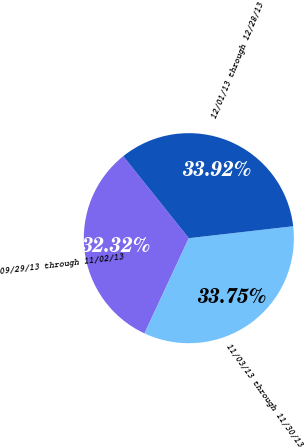Convert chart to OTSL. <chart><loc_0><loc_0><loc_500><loc_500><pie_chart><fcel>09/29/13 through 11/02/13<fcel>11/03/13 through 11/30/13<fcel>12/01/13 through 12/28/13<nl><fcel>32.32%<fcel>33.75%<fcel>33.92%<nl></chart> 